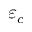<formula> <loc_0><loc_0><loc_500><loc_500>\varepsilon _ { c }</formula> 